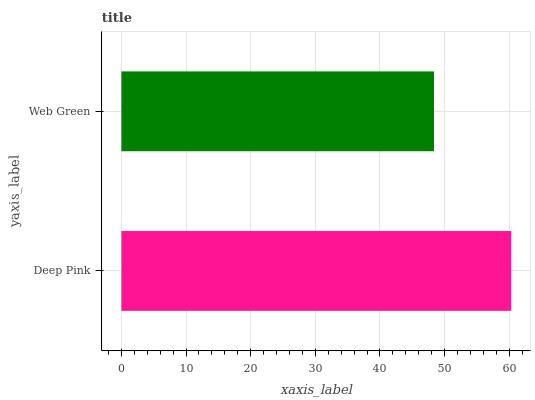Is Web Green the minimum?
Answer yes or no. Yes. Is Deep Pink the maximum?
Answer yes or no. Yes. Is Web Green the maximum?
Answer yes or no. No. Is Deep Pink greater than Web Green?
Answer yes or no. Yes. Is Web Green less than Deep Pink?
Answer yes or no. Yes. Is Web Green greater than Deep Pink?
Answer yes or no. No. Is Deep Pink less than Web Green?
Answer yes or no. No. Is Deep Pink the high median?
Answer yes or no. Yes. Is Web Green the low median?
Answer yes or no. Yes. Is Web Green the high median?
Answer yes or no. No. Is Deep Pink the low median?
Answer yes or no. No. 